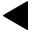<formula> <loc_0><loc_0><loc_500><loc_500>\blacktriangleleft</formula> 